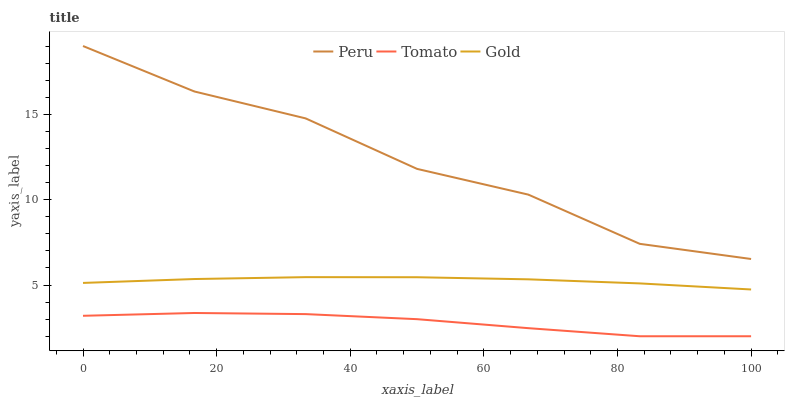Does Tomato have the minimum area under the curve?
Answer yes or no. Yes. Does Peru have the maximum area under the curve?
Answer yes or no. Yes. Does Gold have the minimum area under the curve?
Answer yes or no. No. Does Gold have the maximum area under the curve?
Answer yes or no. No. Is Gold the smoothest?
Answer yes or no. Yes. Is Peru the roughest?
Answer yes or no. Yes. Is Peru the smoothest?
Answer yes or no. No. Is Gold the roughest?
Answer yes or no. No. Does Gold have the lowest value?
Answer yes or no. No. Does Peru have the highest value?
Answer yes or no. Yes. Does Gold have the highest value?
Answer yes or no. No. Is Gold less than Peru?
Answer yes or no. Yes. Is Gold greater than Tomato?
Answer yes or no. Yes. Does Gold intersect Peru?
Answer yes or no. No. 